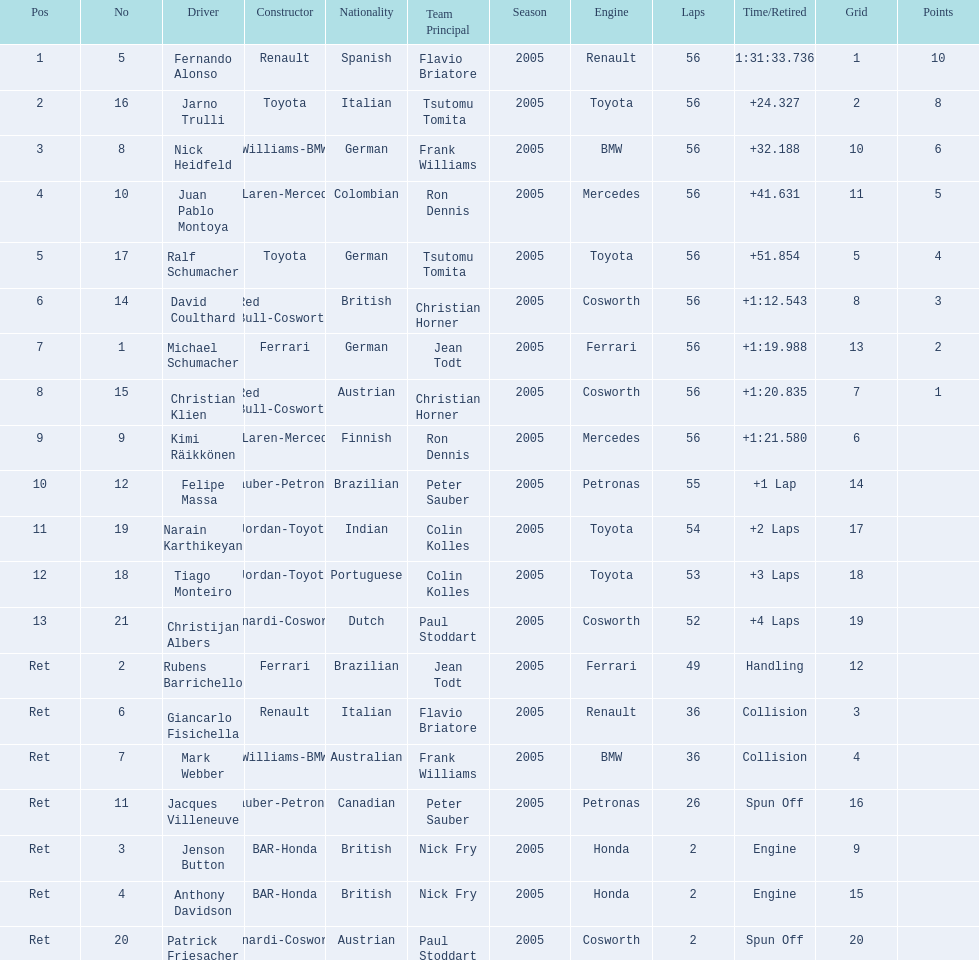What place did fernando alonso finish? 1. How long did it take alonso to finish the race? 1:31:33.736. 